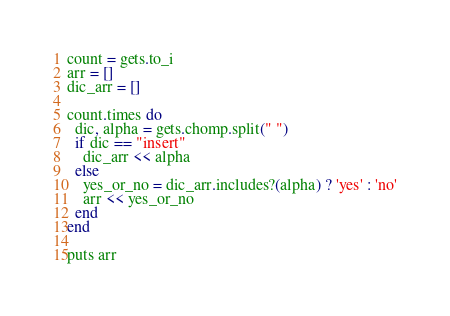Convert code to text. <code><loc_0><loc_0><loc_500><loc_500><_Ruby_>
count = gets.to_i
arr = []
dic_arr = []

count.times do
  dic, alpha = gets.chomp.split(" ")
  if dic == "insert"
    dic_arr << alpha
  else
    yes_or_no = dic_arr.includes?(alpha) ? 'yes' : 'no'
    arr << yes_or_no
  end
end

puts arr</code> 